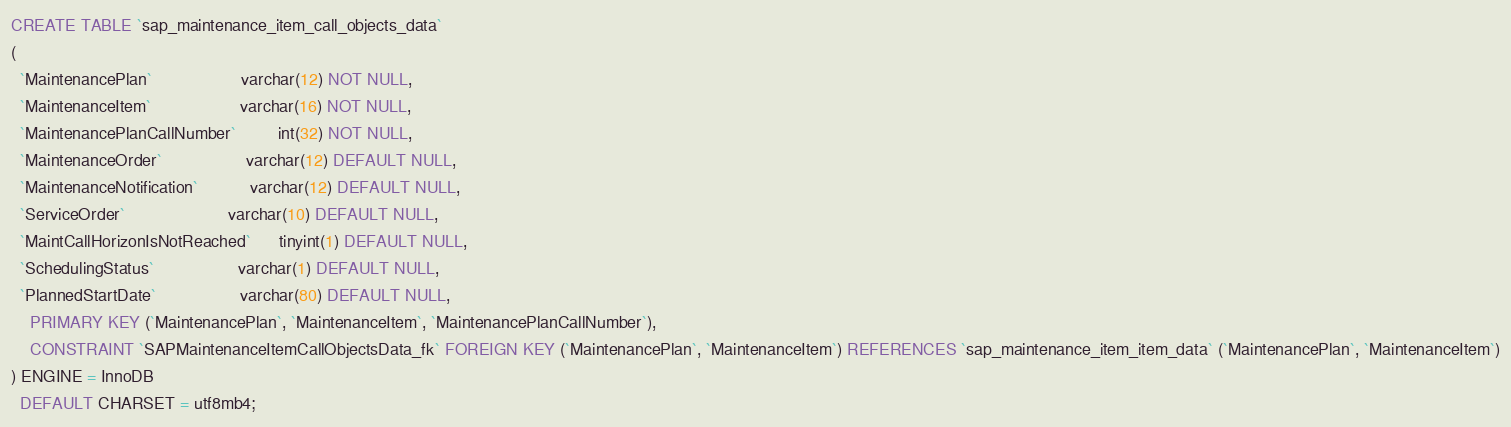<code> <loc_0><loc_0><loc_500><loc_500><_SQL_>CREATE TABLE `sap_maintenance_item_call_objects_data`
(
  `MaintenancePlan`                   varchar(12) NOT NULL,
  `MaintenanceItem`                   varchar(16) NOT NULL,
  `MaintenancePlanCallNumber`         int(32) NOT NULL,
  `MaintenanceOrder`                  varchar(12) DEFAULT NULL,
  `MaintenanceNotification`           varchar(12) DEFAULT NULL,
  `ServiceOrder`                      varchar(10) DEFAULT NULL,
  `MaintCallHorizonIsNotReached`      tinyint(1) DEFAULT NULL,
  `SchedulingStatus`                  varchar(1) DEFAULT NULL,
  `PlannedStartDate`                  varchar(80) DEFAULT NULL,
    PRIMARY KEY (`MaintenancePlan`, `MaintenanceItem`, `MaintenancePlanCallNumber`),
    CONSTRAINT `SAPMaintenanceItemCallObjectsData_fk` FOREIGN KEY (`MaintenancePlan`, `MaintenanceItem`) REFERENCES `sap_maintenance_item_item_data` (`MaintenancePlan`, `MaintenanceItem`)
) ENGINE = InnoDB
  DEFAULT CHARSET = utf8mb4;
</code> 